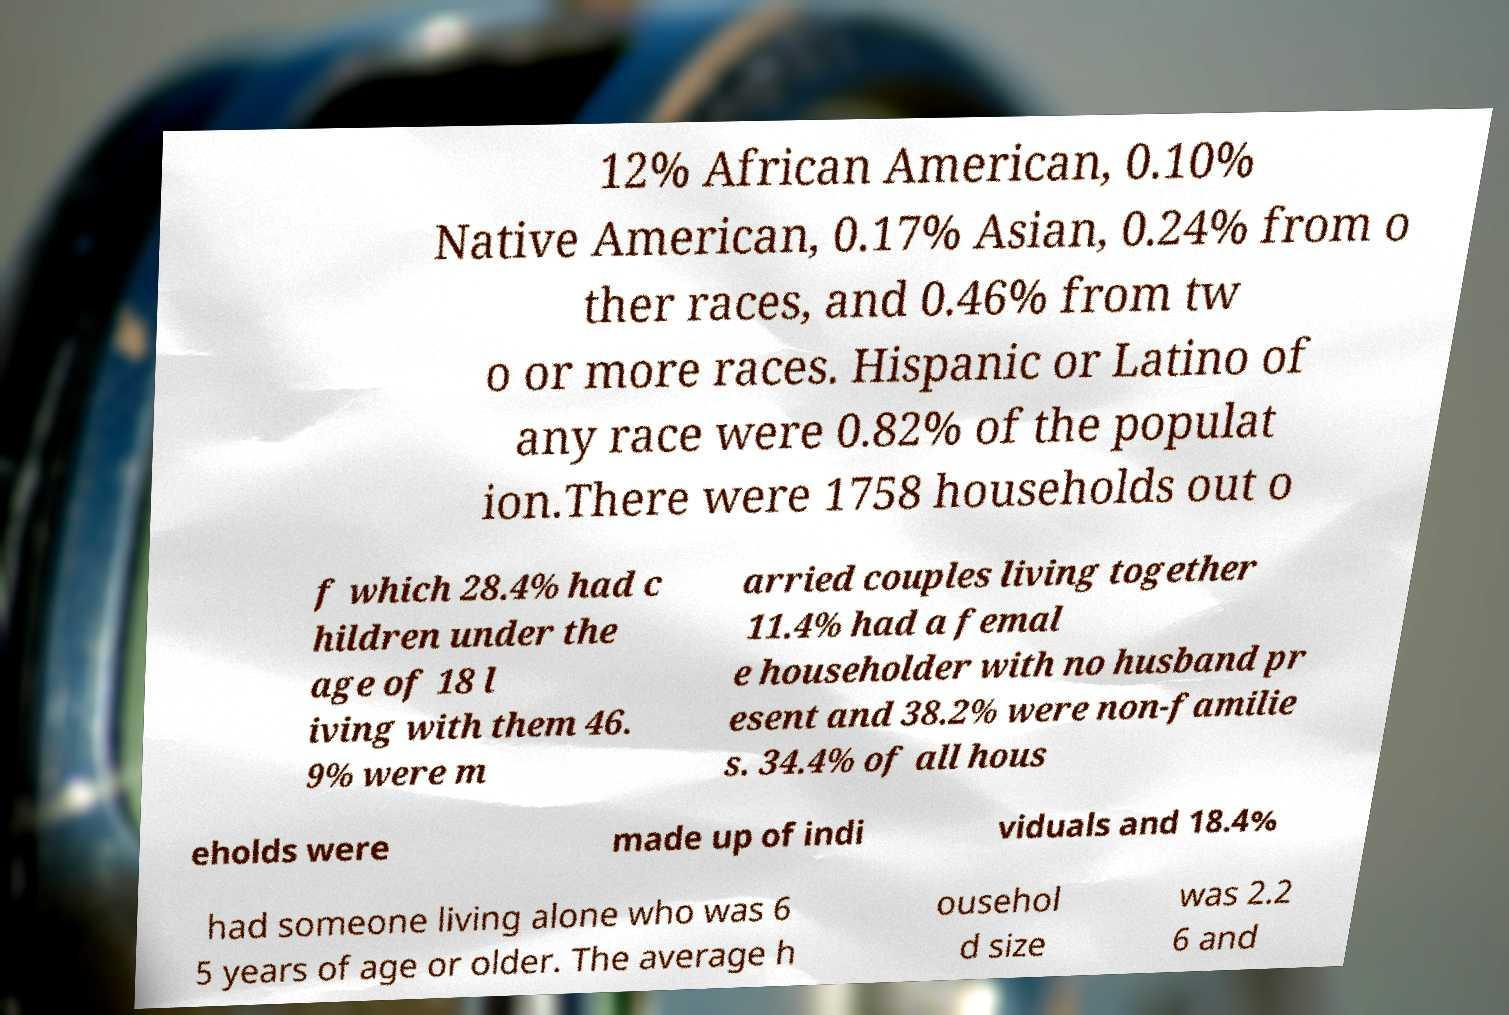There's text embedded in this image that I need extracted. Can you transcribe it verbatim? 12% African American, 0.10% Native American, 0.17% Asian, 0.24% from o ther races, and 0.46% from tw o or more races. Hispanic or Latino of any race were 0.82% of the populat ion.There were 1758 households out o f which 28.4% had c hildren under the age of 18 l iving with them 46. 9% were m arried couples living together 11.4% had a femal e householder with no husband pr esent and 38.2% were non-familie s. 34.4% of all hous eholds were made up of indi viduals and 18.4% had someone living alone who was 6 5 years of age or older. The average h ousehol d size was 2.2 6 and 